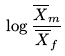<formula> <loc_0><loc_0><loc_500><loc_500>\log \frac { \overline { X } _ { m } } { \overline { X } _ { f } }</formula> 